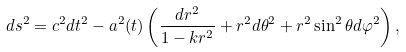<formula> <loc_0><loc_0><loc_500><loc_500>d s ^ { 2 } = c ^ { 2 } d t ^ { 2 } - a ^ { 2 } ( t ) \left ( \frac { d r ^ { 2 } } { 1 - k r ^ { 2 } } + r ^ { 2 } d \theta ^ { 2 } + r ^ { 2 } \sin ^ { 2 } { \theta } d \varphi ^ { 2 } \right ) ,</formula> 